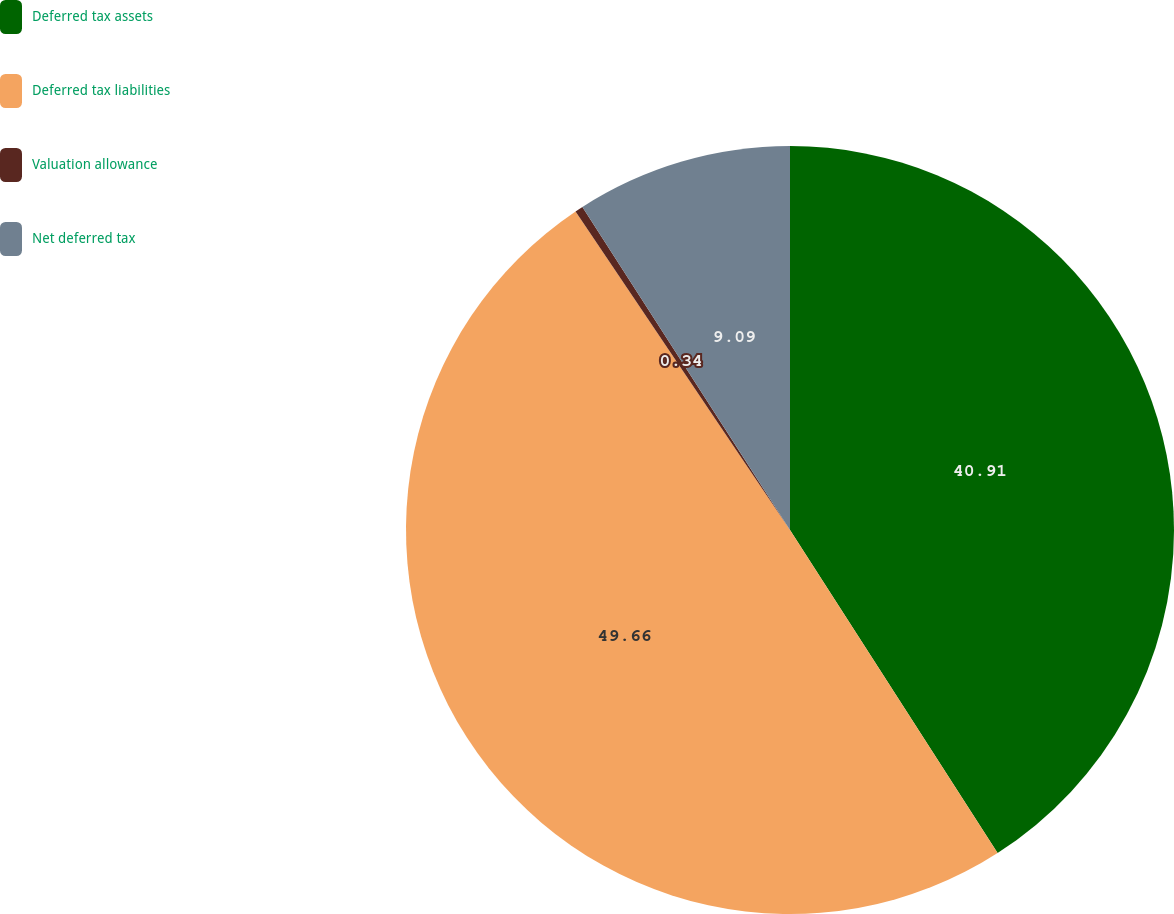Convert chart. <chart><loc_0><loc_0><loc_500><loc_500><pie_chart><fcel>Deferred tax assets<fcel>Deferred tax liabilities<fcel>Valuation allowance<fcel>Net deferred tax<nl><fcel>40.91%<fcel>49.66%<fcel>0.34%<fcel>9.09%<nl></chart> 